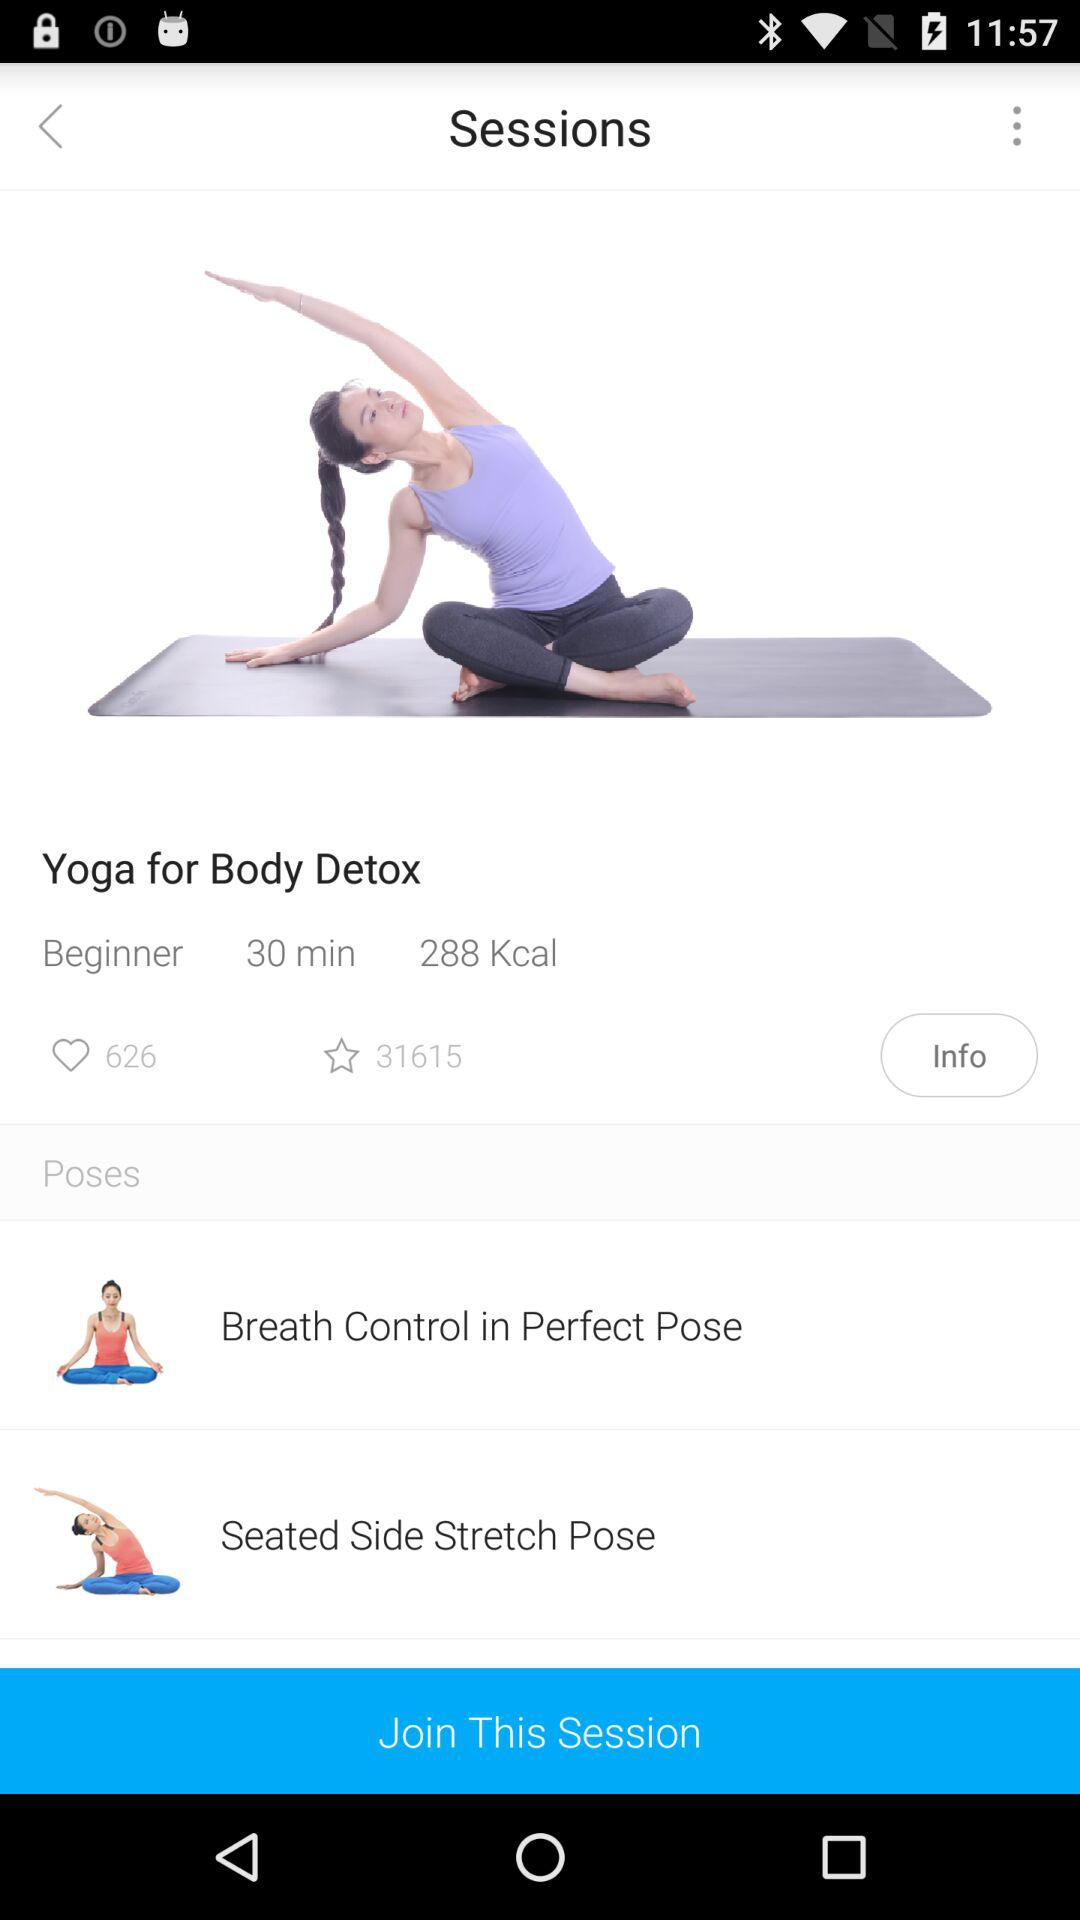What is the duration of the session for beginners? The duration is 30 minutes. 